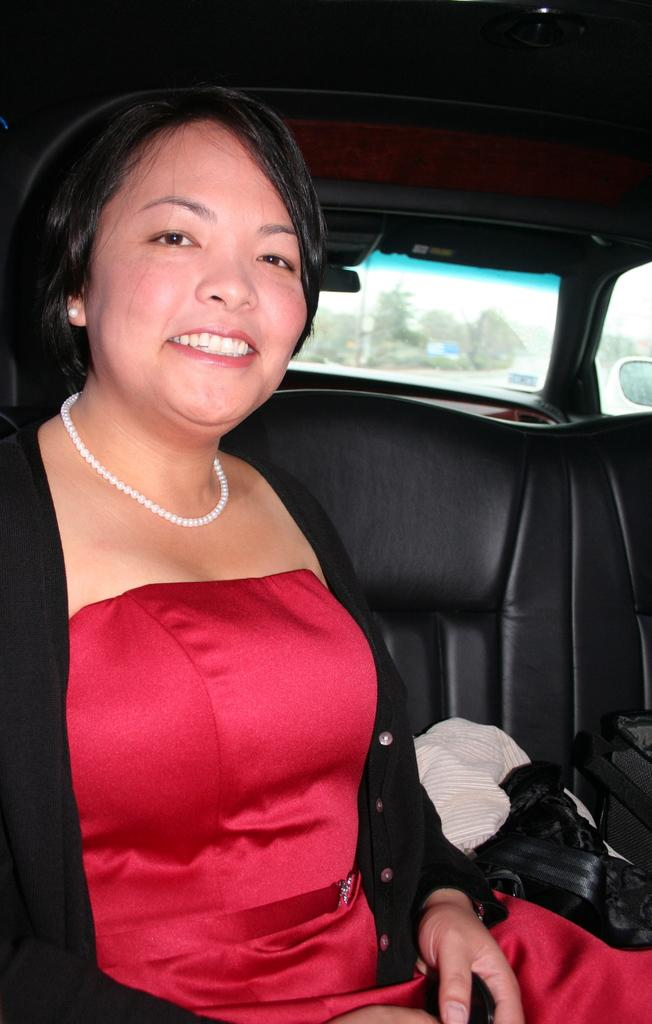Who is the main subject in the image? There is a lady in the center of the image. What is the lady doing in the image? The lady is sitting in a vehicle and smiling. What can be seen in the background of the image? There is glass and a mirror in the background of the image. What type of calculator is the lady holding in the image? There is no calculator present in the image. What part of the lady's face is emphasized in the mirror? The mirror in the background does not show any part of the lady's face, as it is not focused on her. 